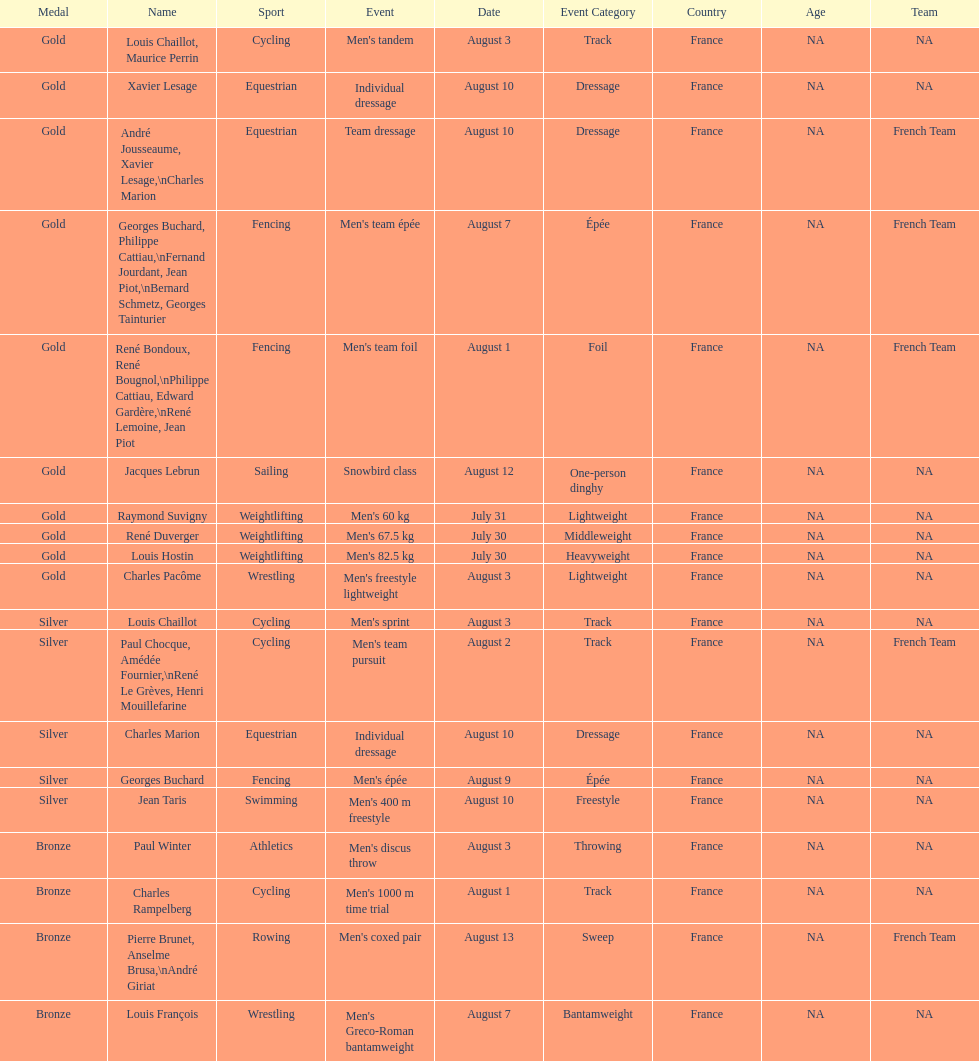Louis chaillot won a gold medal for cycling and a silver medal for what sport? Cycling. 